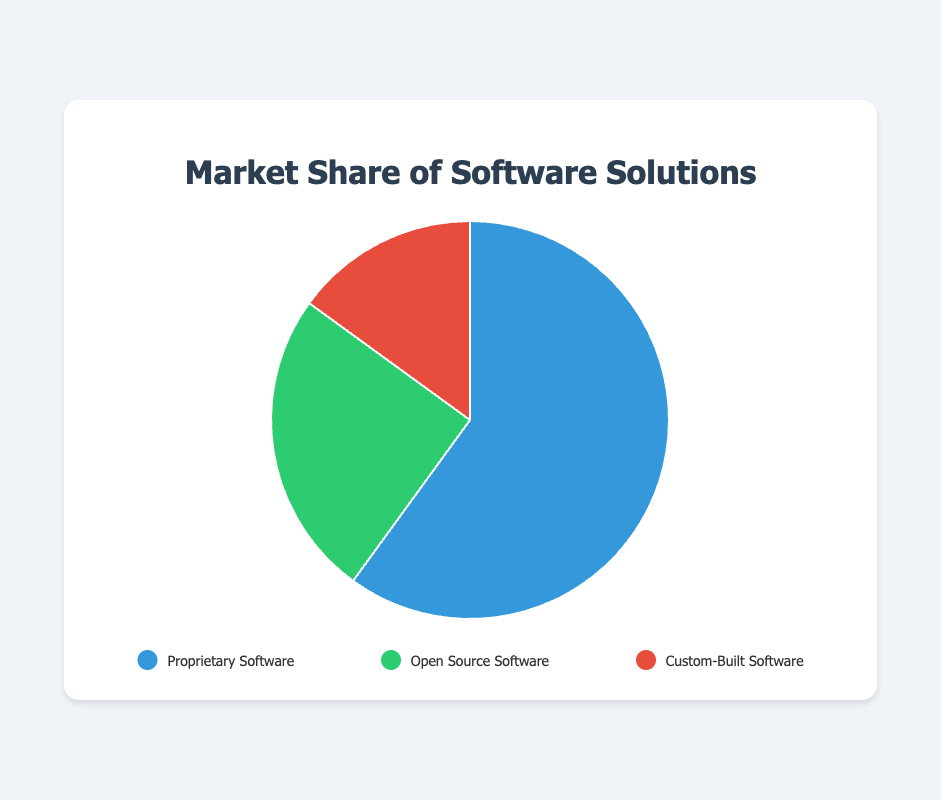what category has the largest market share? By looking at the pie chart, the slice representing "Proprietary Software" is the largest, indicating it has the largest market share.
Answer: Proprietary Software Compare the market share between Open Source and Custom-Built software. Which one is larger and by how much? The market share of Open Source Software is 25%, while Custom-Built Software is 15%. The difference can be calculated as 25% - 15% = 10%.
Answer: Open Source Software, by 10% What is the combined market share of Proprietary and Custom-Built software? To find the combined market share, add the percentages of Proprietary Software (60%) and Custom-Built Software (15%): 60% + 15% = 75%.
Answer: 75% If the market share of Open Source Software were to double, what would its new market share be? If we double the market share of Open Source Software, which is 25%, the new market share would be 25% * 2 = 50%.
Answer: 50% What fraction of the total market share is made up by Custom-Built software? Custom-Built Software makes up 15% of the total market share. To convert this percentage to a fraction, divide by 100: 15/100 = 3/20.
Answer: 3/20 Is the market share of Open Source Software more than one-third of that of Proprietary Software? Proprietary Software has a market share of 60%. One-third of this is 60% / 3 = 20%. Since Open Source Software has a market share of 25%, it is indeed more than one-third of Proprietary Software's share.
Answer: Yes What color represents Proprietary Software in the pie chart? By looking at the legend, the color representing "Proprietary Software" is blue.
Answer: Blue How much larger is the market share of Proprietary Software compared to Open Source Software? Proprietary Software has a market share of 60% and Open Source Software has 25%. The difference is 60% - 25% = 35%.
Answer: 35% Which category would you find applications like Microsoft Office and Salesforce? As per the examples given, applications like Microsoft Office and Salesforce fall under "Proprietary Software."
Answer: Proprietary Software 